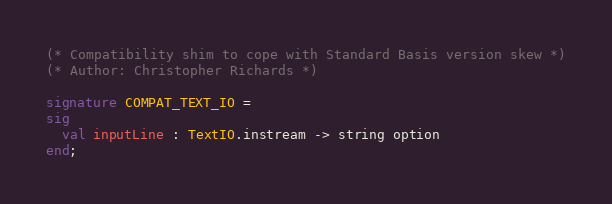Convert code to text. <code><loc_0><loc_0><loc_500><loc_500><_SML_>(* Compatibility shim to cope with Standard Basis version skew *)
(* Author: Christopher Richards *)

signature COMPAT_TEXT_IO =
sig
  val inputLine : TextIO.instream -> string option
end;
</code> 